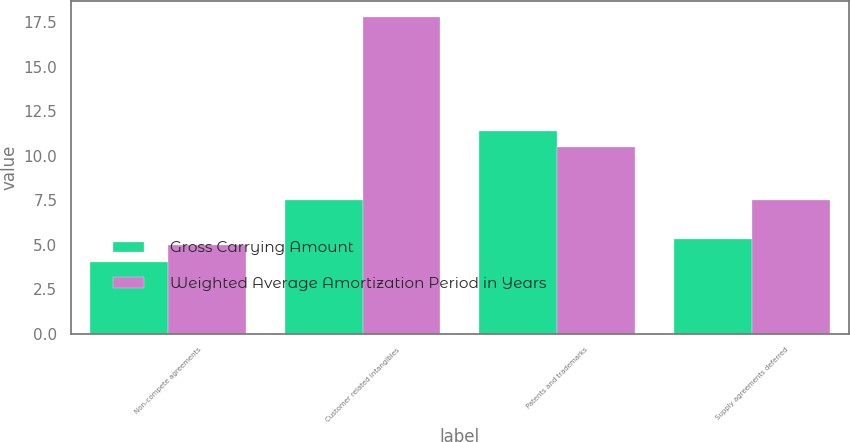<chart> <loc_0><loc_0><loc_500><loc_500><stacked_bar_chart><ecel><fcel>Non-compete agreements<fcel>Customer related intangibles<fcel>Patents and trademarks<fcel>Supply agreements deferred<nl><fcel>Gross Carrying Amount<fcel>4<fcel>7.5<fcel>11.4<fcel>5.3<nl><fcel>Weighted Average Amortization Period in Years<fcel>5<fcel>17.8<fcel>10.5<fcel>7.5<nl></chart> 